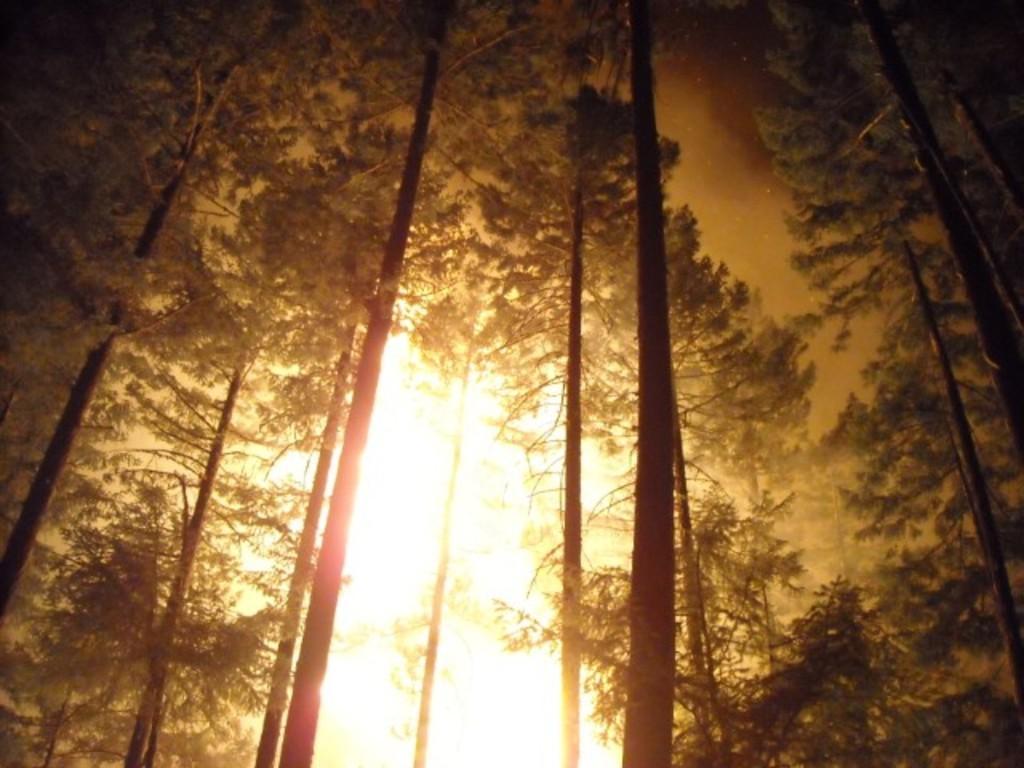In one or two sentences, can you explain what this image depicts? In this picture we can see a few trees from left to right. 